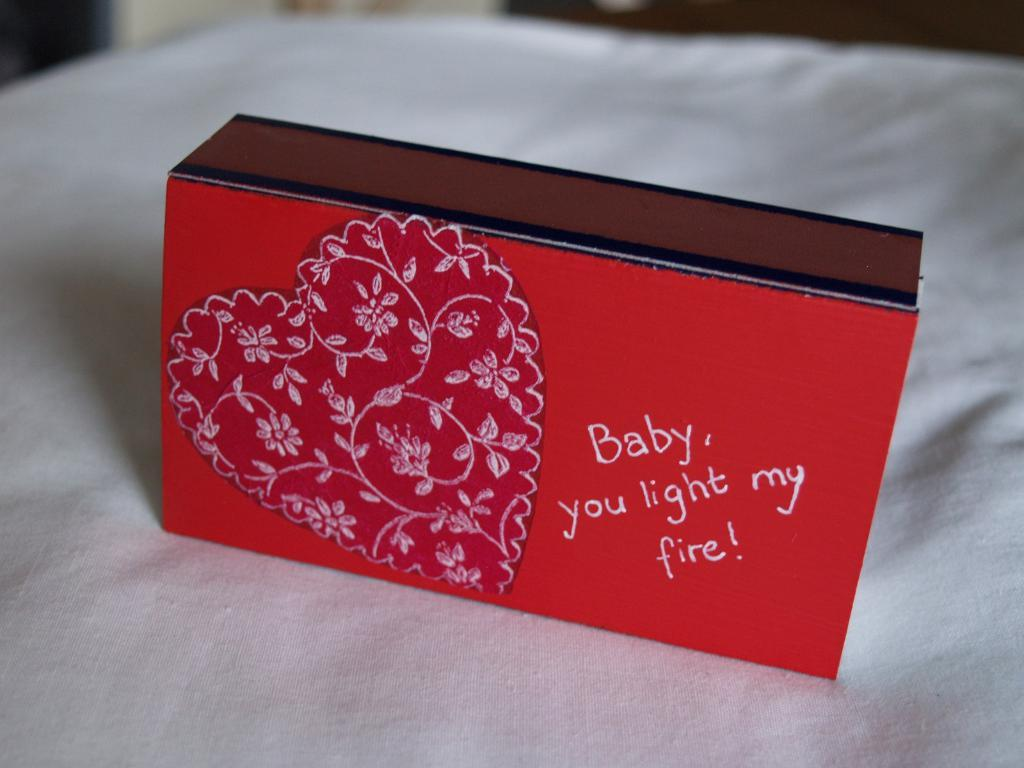<image>
Describe the image concisely. A valentine's surprise must be hidden in this red heart-adorned match box, with the wording 'Baby you light my fire!' 